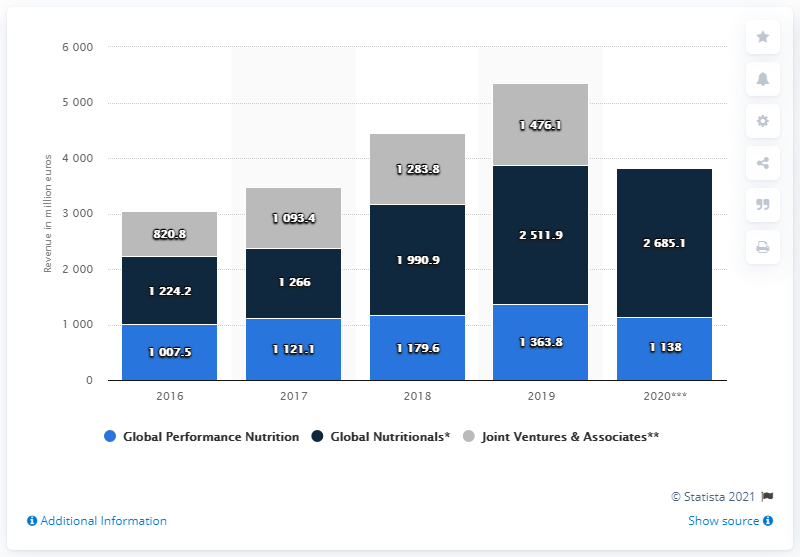Mention a couple of crucial points in this snapshot. In 2020, Glanbia generated approximately $1138 in revenue. 